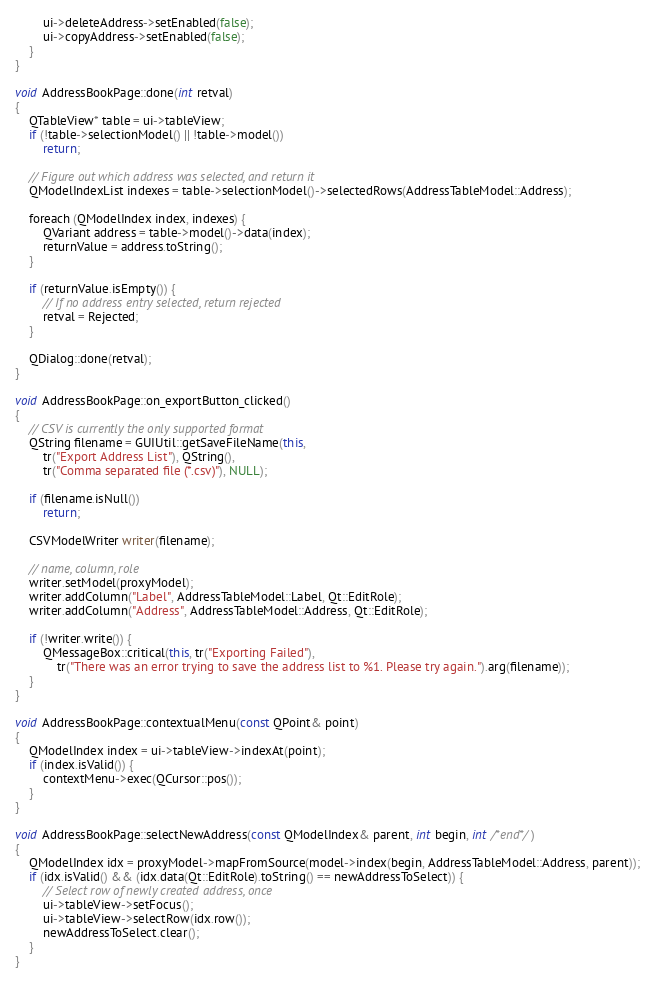Convert code to text. <code><loc_0><loc_0><loc_500><loc_500><_C++_>        ui->deleteAddress->setEnabled(false);
        ui->copyAddress->setEnabled(false);
    }
}

void AddressBookPage::done(int retval)
{
    QTableView* table = ui->tableView;
    if (!table->selectionModel() || !table->model())
        return;

    // Figure out which address was selected, and return it
    QModelIndexList indexes = table->selectionModel()->selectedRows(AddressTableModel::Address);

    foreach (QModelIndex index, indexes) {
        QVariant address = table->model()->data(index);
        returnValue = address.toString();
    }

    if (returnValue.isEmpty()) {
        // If no address entry selected, return rejected
        retval = Rejected;
    }

    QDialog::done(retval);
}

void AddressBookPage::on_exportButton_clicked()
{
    // CSV is currently the only supported format
    QString filename = GUIUtil::getSaveFileName(this,
        tr("Export Address List"), QString(),
        tr("Comma separated file (*.csv)"), NULL);

    if (filename.isNull())
        return;

    CSVModelWriter writer(filename);

    // name, column, role
    writer.setModel(proxyModel);
    writer.addColumn("Label", AddressTableModel::Label, Qt::EditRole);
    writer.addColumn("Address", AddressTableModel::Address, Qt::EditRole);

    if (!writer.write()) {
        QMessageBox::critical(this, tr("Exporting Failed"),
            tr("There was an error trying to save the address list to %1. Please try again.").arg(filename));
    }
}

void AddressBookPage::contextualMenu(const QPoint& point)
{
    QModelIndex index = ui->tableView->indexAt(point);
    if (index.isValid()) {
        contextMenu->exec(QCursor::pos());
    }
}

void AddressBookPage::selectNewAddress(const QModelIndex& parent, int begin, int /*end*/)
{
    QModelIndex idx = proxyModel->mapFromSource(model->index(begin, AddressTableModel::Address, parent));
    if (idx.isValid() && (idx.data(Qt::EditRole).toString() == newAddressToSelect)) {
        // Select row of newly created address, once
        ui->tableView->setFocus();
        ui->tableView->selectRow(idx.row());
        newAddressToSelect.clear();
    }
}
</code> 